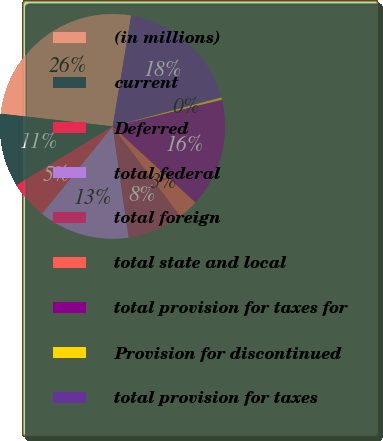<chart> <loc_0><loc_0><loc_500><loc_500><pie_chart><fcel>(in millions)<fcel>current<fcel>Deferred<fcel>total federal<fcel>total foreign<fcel>total state and local<fcel>total provision for taxes for<fcel>Provision for discontinued<fcel>total provision for taxes<nl><fcel>25.84%<fcel>10.54%<fcel>5.45%<fcel>13.09%<fcel>8.0%<fcel>2.9%<fcel>15.64%<fcel>0.35%<fcel>18.19%<nl></chart> 